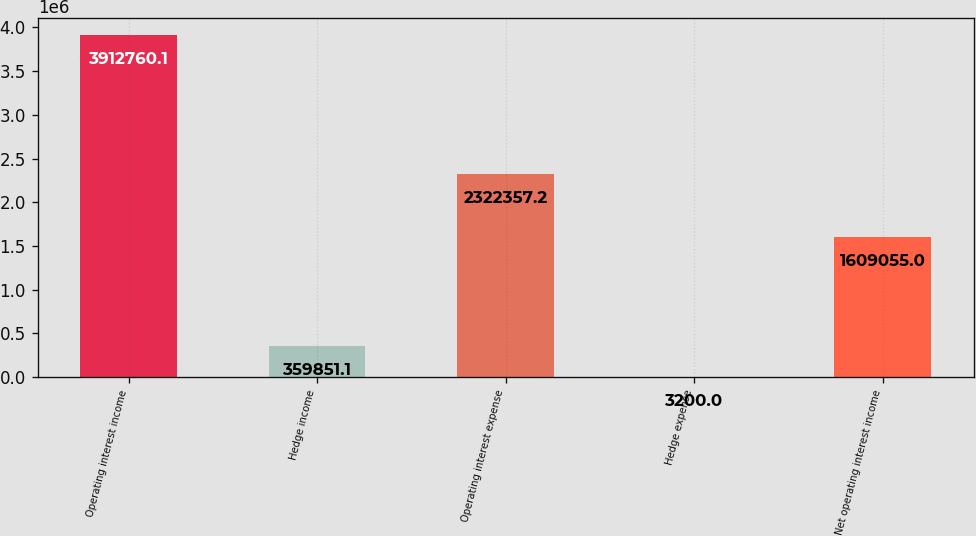Convert chart. <chart><loc_0><loc_0><loc_500><loc_500><bar_chart><fcel>Operating interest income<fcel>Hedge income<fcel>Operating interest expense<fcel>Hedge expense<fcel>Net operating interest income<nl><fcel>3.91276e+06<fcel>359851<fcel>2.32236e+06<fcel>3200<fcel>1.60906e+06<nl></chart> 